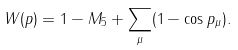Convert formula to latex. <formula><loc_0><loc_0><loc_500><loc_500>W ( p ) = 1 - M _ { 5 } + \sum _ { \mu } ( 1 - \cos p _ { \mu } ) .</formula> 